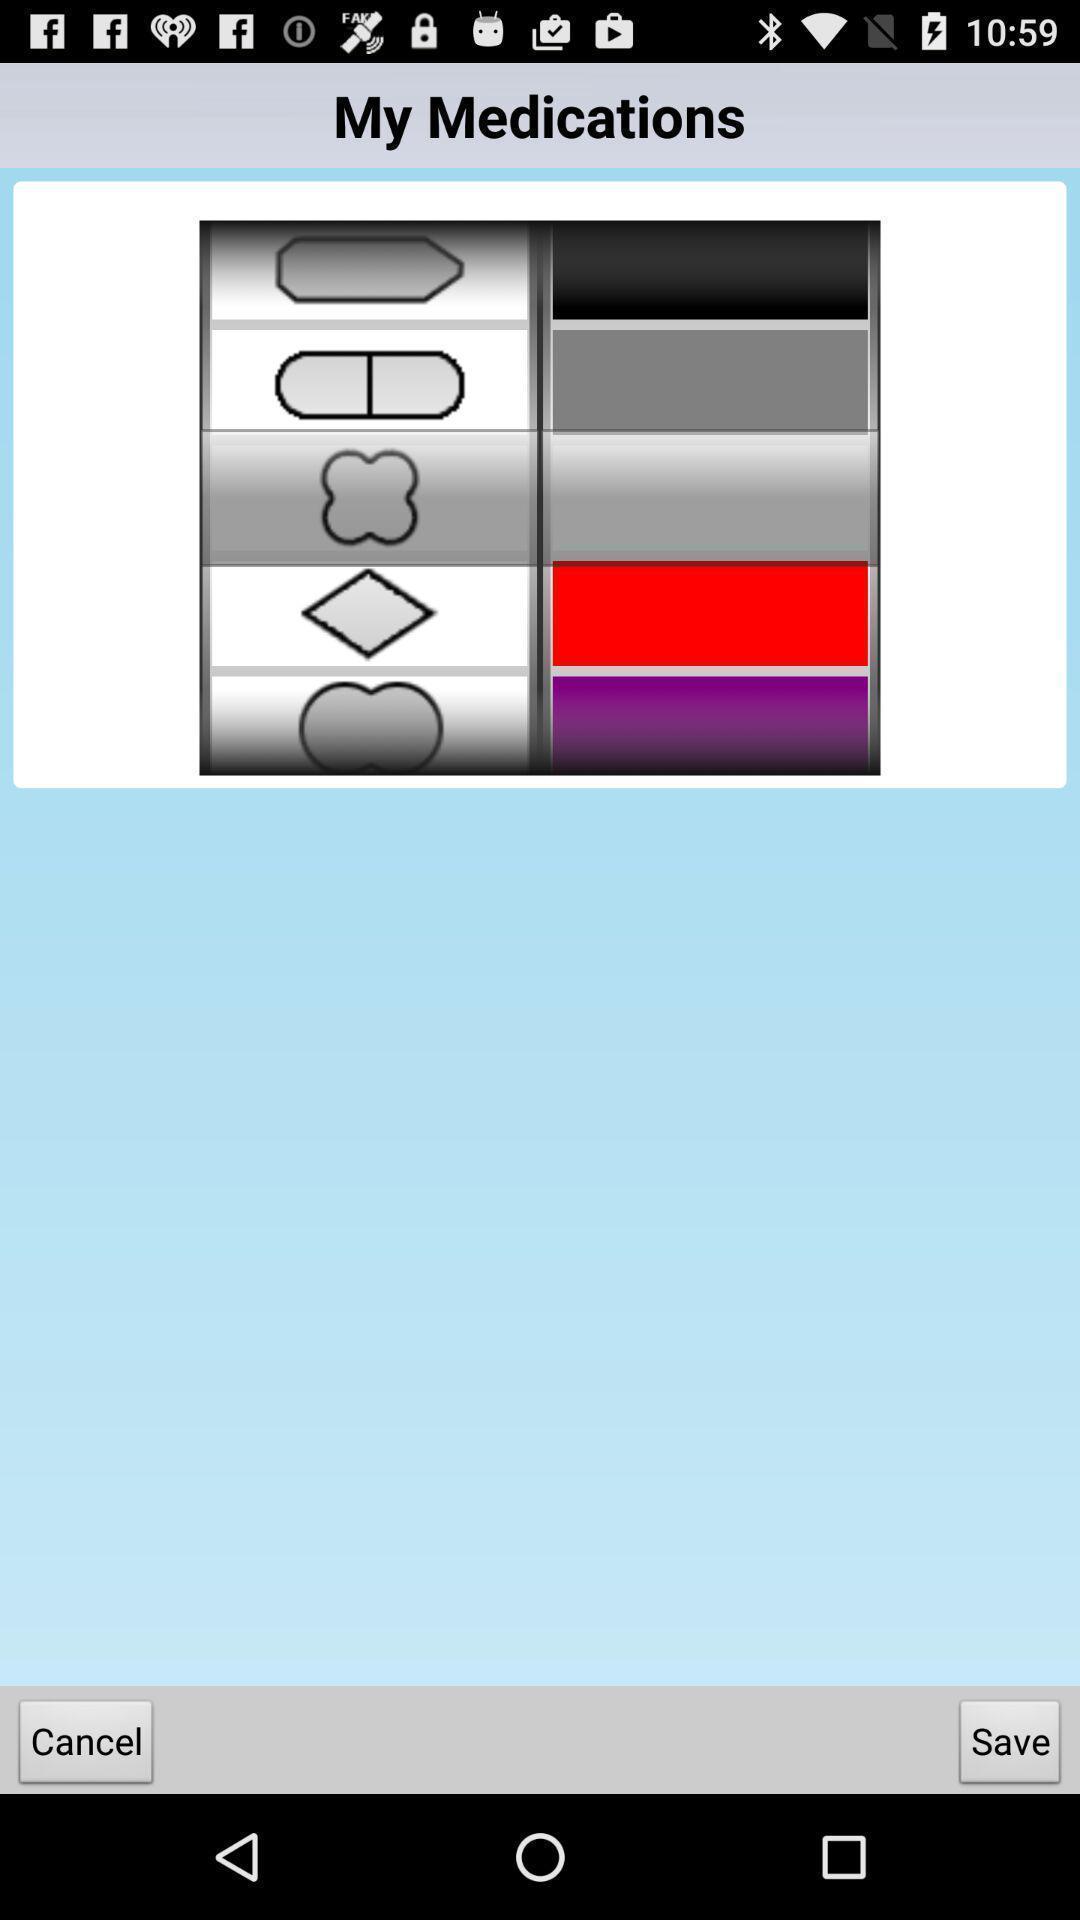Provide a detailed account of this screenshot. Screen shows about medications on a device. 